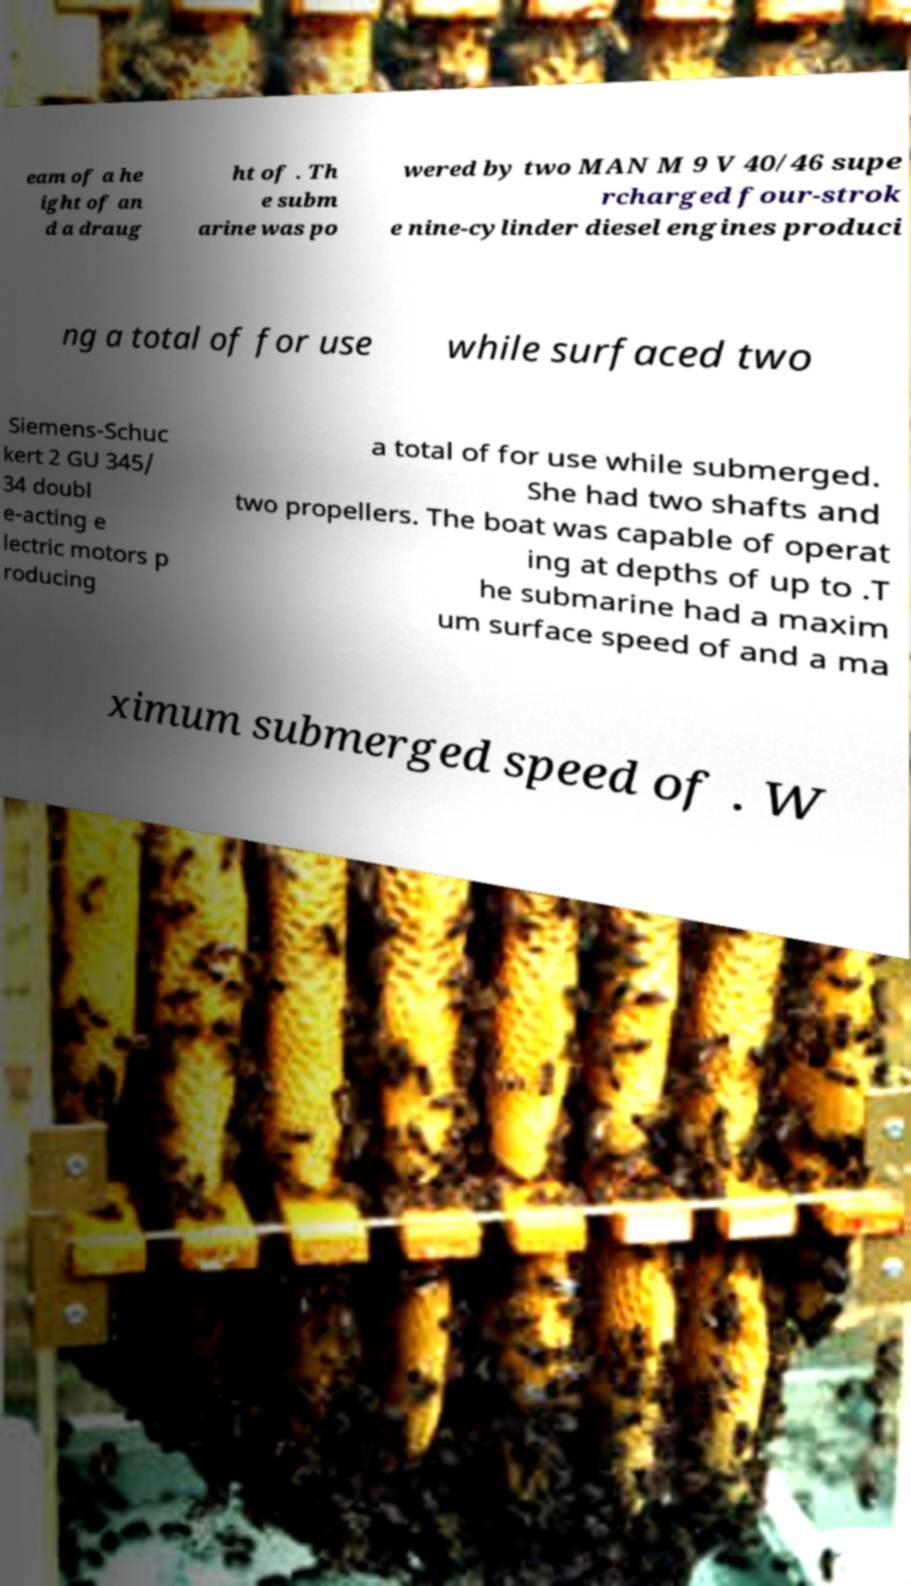Can you read and provide the text displayed in the image?This photo seems to have some interesting text. Can you extract and type it out for me? eam of a he ight of an d a draug ht of . Th e subm arine was po wered by two MAN M 9 V 40/46 supe rcharged four-strok e nine-cylinder diesel engines produci ng a total of for use while surfaced two Siemens-Schuc kert 2 GU 345/ 34 doubl e-acting e lectric motors p roducing a total of for use while submerged. She had two shafts and two propellers. The boat was capable of operat ing at depths of up to .T he submarine had a maxim um surface speed of and a ma ximum submerged speed of . W 